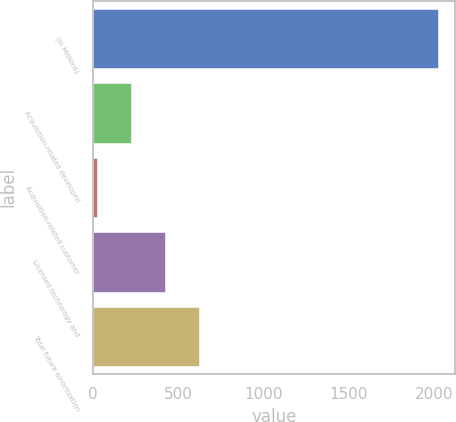<chart> <loc_0><loc_0><loc_500><loc_500><bar_chart><fcel>(In Millions)<fcel>Acquisition-related developed<fcel>Acquisition-related customer<fcel>Licensed technology and<fcel>Total future amortization<nl><fcel>2020<fcel>221.8<fcel>22<fcel>421.6<fcel>621.4<nl></chart> 